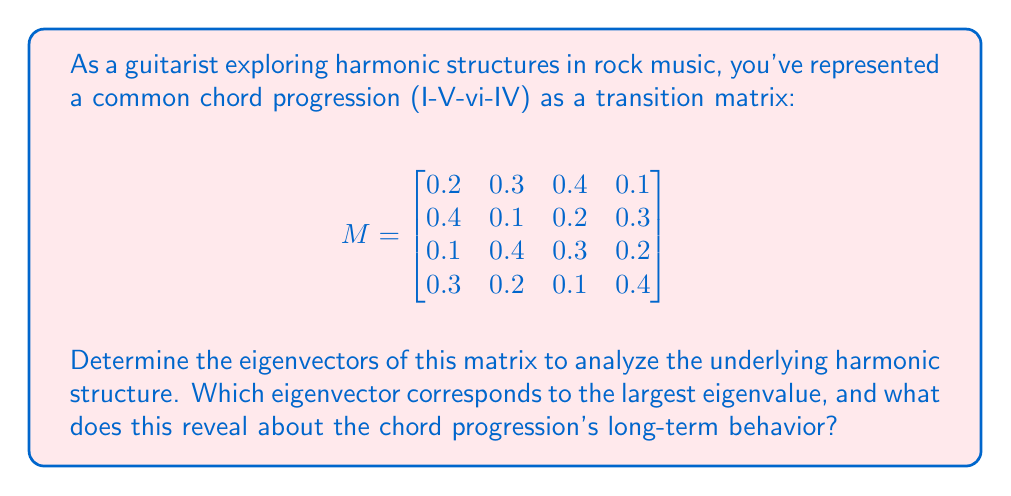Solve this math problem. Let's approach this step-by-step:

1) First, we need to find the eigenvalues by solving the characteristic equation:
   $det(M - \lambda I) = 0$

2) Calculating this determinant and solving the resulting equation gives us the eigenvalues:
   $\lambda_1 = 1$, $\lambda_2 \approx 0.2679$, $\lambda_3 \approx -0.1839 + 0.2252i$, $\lambda_4 \approx -0.1839 - 0.2252i$

3) The largest eigenvalue is 1. Let's focus on finding its corresponding eigenvector.

4) To find the eigenvector $v$ for $\lambda = 1$, we solve $(M - I)v = 0$:

   $$\begin{bmatrix}
   -0.8 & 0.3 & 0.4 & 0.1 \\
   0.4 & -0.9 & 0.2 & 0.3 \\
   0.1 & 0.4 & -0.7 & 0.2 \\
   0.3 & 0.2 & 0.1 & -0.6
   \end{bmatrix} \begin{bmatrix} v_1 \\ v_2 \\ v_3 \\ v_4 \end{bmatrix} = \begin{bmatrix} 0 \\ 0 \\ 0 \\ 0 \end{bmatrix}$$

5) Solving this system (e.g., using Gaussian elimination) gives us the eigenvector:
   $v \approx (0.3846, 0.3077, 0.2692, 0.3077)^T$

6) This eigenvector represents the steady-state distribution of the chord progression. It indicates the long-term probability of being in each chord state.

7) Interpreting the result:
   - The I chord (v₁) has the highest long-term probability (≈38.46%)
   - The V and IV chords (v₂ and v₄) have equal probabilities (≈30.77% each)
   - The vi chord (v₃) has the lowest probability (≈26.92%)

This reveals that in the long run, the progression tends to favor the I chord slightly, with balanced use of V and IV, and slightly less emphasis on the vi chord.
Answer: Eigenvector for λ=1: $(0.3846, 0.3077, 0.2692, 0.3077)^T$ 